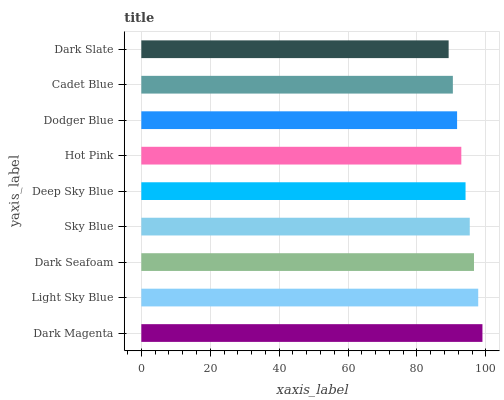Is Dark Slate the minimum?
Answer yes or no. Yes. Is Dark Magenta the maximum?
Answer yes or no. Yes. Is Light Sky Blue the minimum?
Answer yes or no. No. Is Light Sky Blue the maximum?
Answer yes or no. No. Is Dark Magenta greater than Light Sky Blue?
Answer yes or no. Yes. Is Light Sky Blue less than Dark Magenta?
Answer yes or no. Yes. Is Light Sky Blue greater than Dark Magenta?
Answer yes or no. No. Is Dark Magenta less than Light Sky Blue?
Answer yes or no. No. Is Deep Sky Blue the high median?
Answer yes or no. Yes. Is Deep Sky Blue the low median?
Answer yes or no. Yes. Is Cadet Blue the high median?
Answer yes or no. No. Is Dark Seafoam the low median?
Answer yes or no. No. 